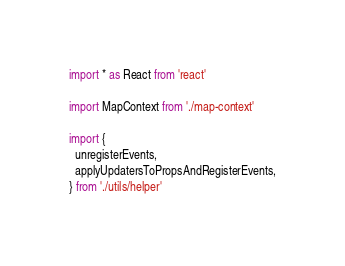Convert code to text. <code><loc_0><loc_0><loc_500><loc_500><_TypeScript_>import * as React from 'react'

import MapContext from './map-context'

import {
  unregisterEvents,
  applyUpdatersToPropsAndRegisterEvents,
} from './utils/helper'</code> 